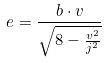Convert formula to latex. <formula><loc_0><loc_0><loc_500><loc_500>e = \frac { b \cdot v } { \sqrt { 8 - \frac { v ^ { 2 } } { j ^ { 2 } } } }</formula> 